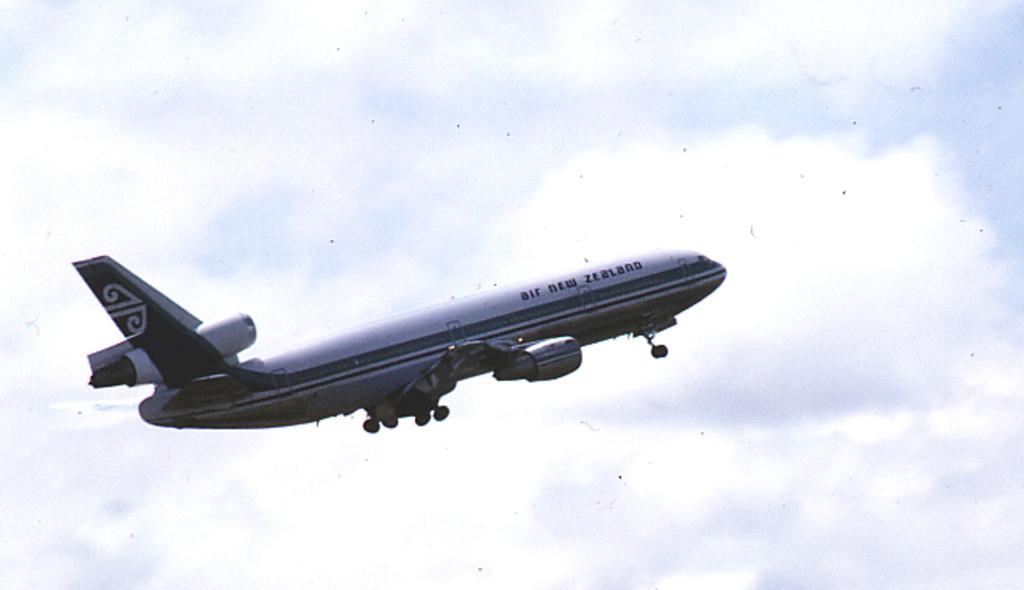Could you give a brief overview of what you see in this image? In this image I can see an aeroplane is flying in the air. In the background I can see the sky. 